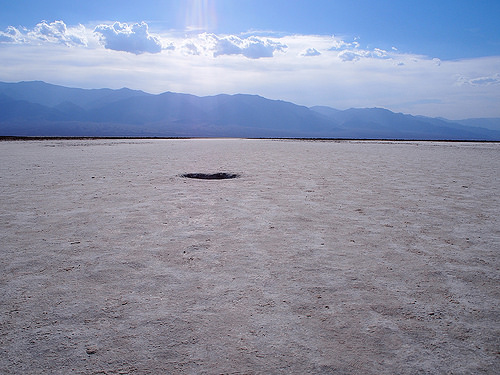<image>
Is the ground next to the mountain? Yes. The ground is positioned adjacent to the mountain, located nearby in the same general area. 